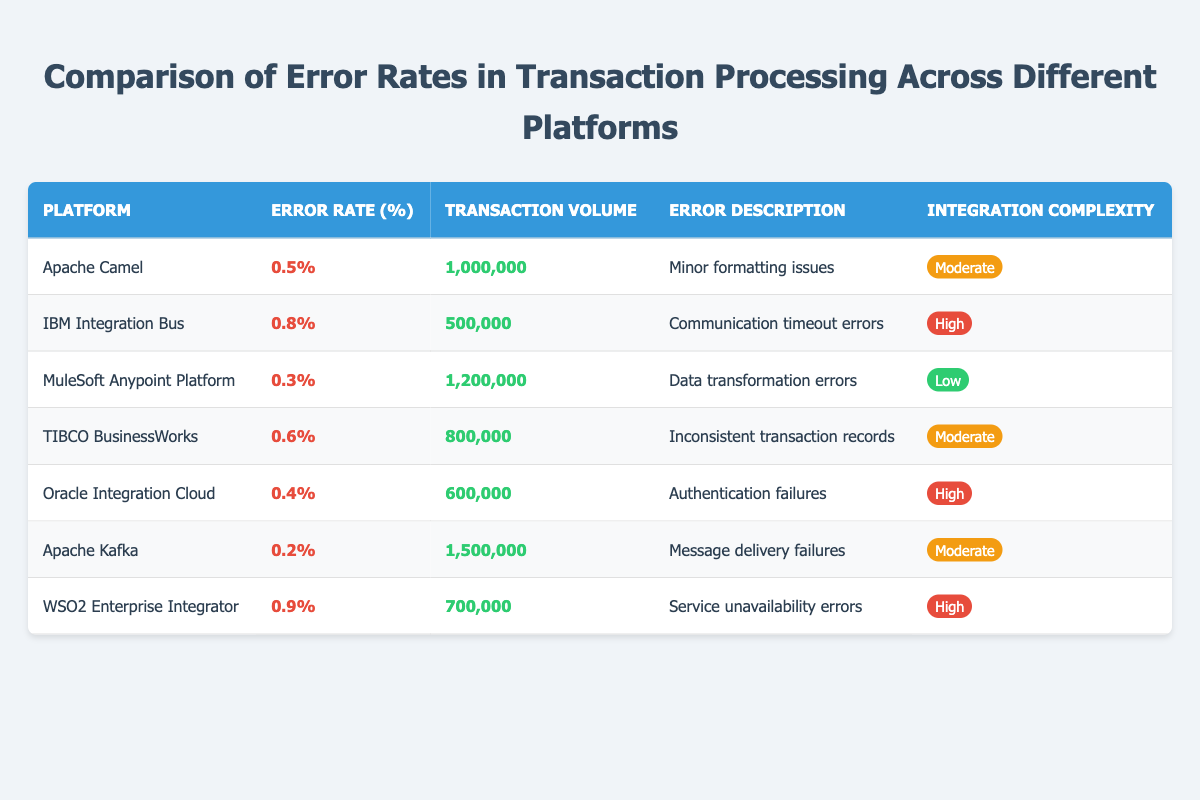What is the error rate for the Apache Camel platform? According to the table, the error rate percentage for the Apache Camel platform is explicitly listed as 0.5%.
Answer: 0.5% How many transactions were processed on the MuleSoft Anypoint Platform? The table specifies that the transaction volume for the MuleSoft Anypoint Platform is 1,200,000 transactions.
Answer: 1,200,000 Which platform has the lowest error rate? By comparing the error rates listed in the table, Apache Kafka has the lowest error rate at 0.2%.
Answer: Apache Kafka Is the integration complexity for IBM Integration Bus high? The table shows that the integration complexity for IBM Integration Bus is categorized as "High," confirming it is indeed high.
Answer: Yes What is the average error rate of all platforms listed? To find the average, sum all error rates: (0.5 + 0.8 + 0.3 + 0.6 + 0.4 + 0.2 + 0.9) = 3.7. Since there are 7 platforms, the average error rate is 3.7 / 7 = 0.52857, which rounds to approximately 0.53%.
Answer: 0.53% Which platform has the highest transaction volume? Looking through the transaction volumes listed, Apache Kafka has the highest volume at 1,500,000 transactions.
Answer: Apache Kafka What are the error descriptions for platforms with high integration complexity? The table lists the error descriptions for high complexity platforms: IBM Integration Bus has "Communication timeout errors," Oracle Integration Cloud has "Authentication failures," and WSO2 Enterprise Integrator has "Service unavailability errors."
Answer: Communication timeout errors, Authentication failures, Service unavailability errors How many platforms have an error rate over 0.6%? By examining the error rates, two platforms exceed 0.6%: IBM Integration Bus (0.8%) and WSO2 Enterprise Integrator (0.9%).
Answer: 2 What is the difference in error rate between the platform with the highest and lowest error rates? The highest error rate is 0.9% (WSO2 Enterprise Integrator) and the lowest is 0.2% (Apache Kafka). The difference is 0.9% - 0.2% = 0.7%.
Answer: 0.7% How many platforms have an error rate below 0.5%? The platforms with an error rate below 0.5% are the MuleSoft Anypoint Platform (0.3%) and Apache Kafka (0.2%). Thus, there are two platforms.
Answer: 2 